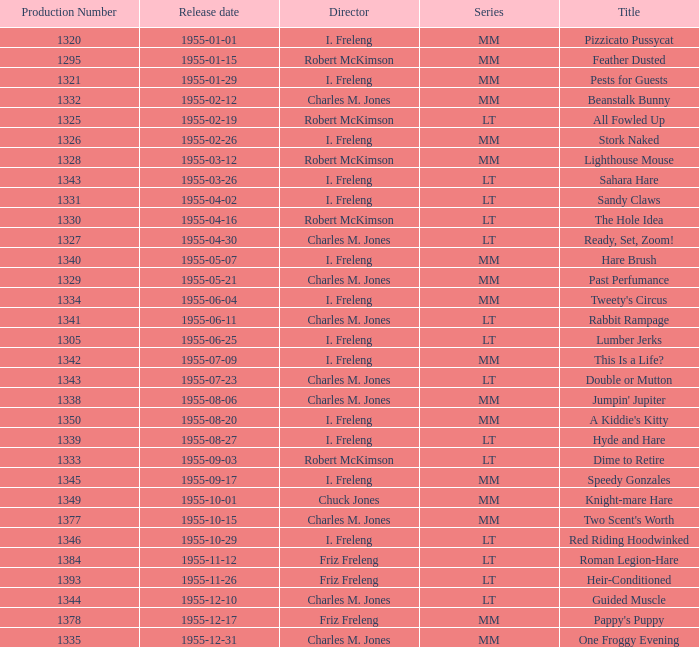What is the highest production number released on 1955-04-02 with i. freleng as the director? 1331.0. 